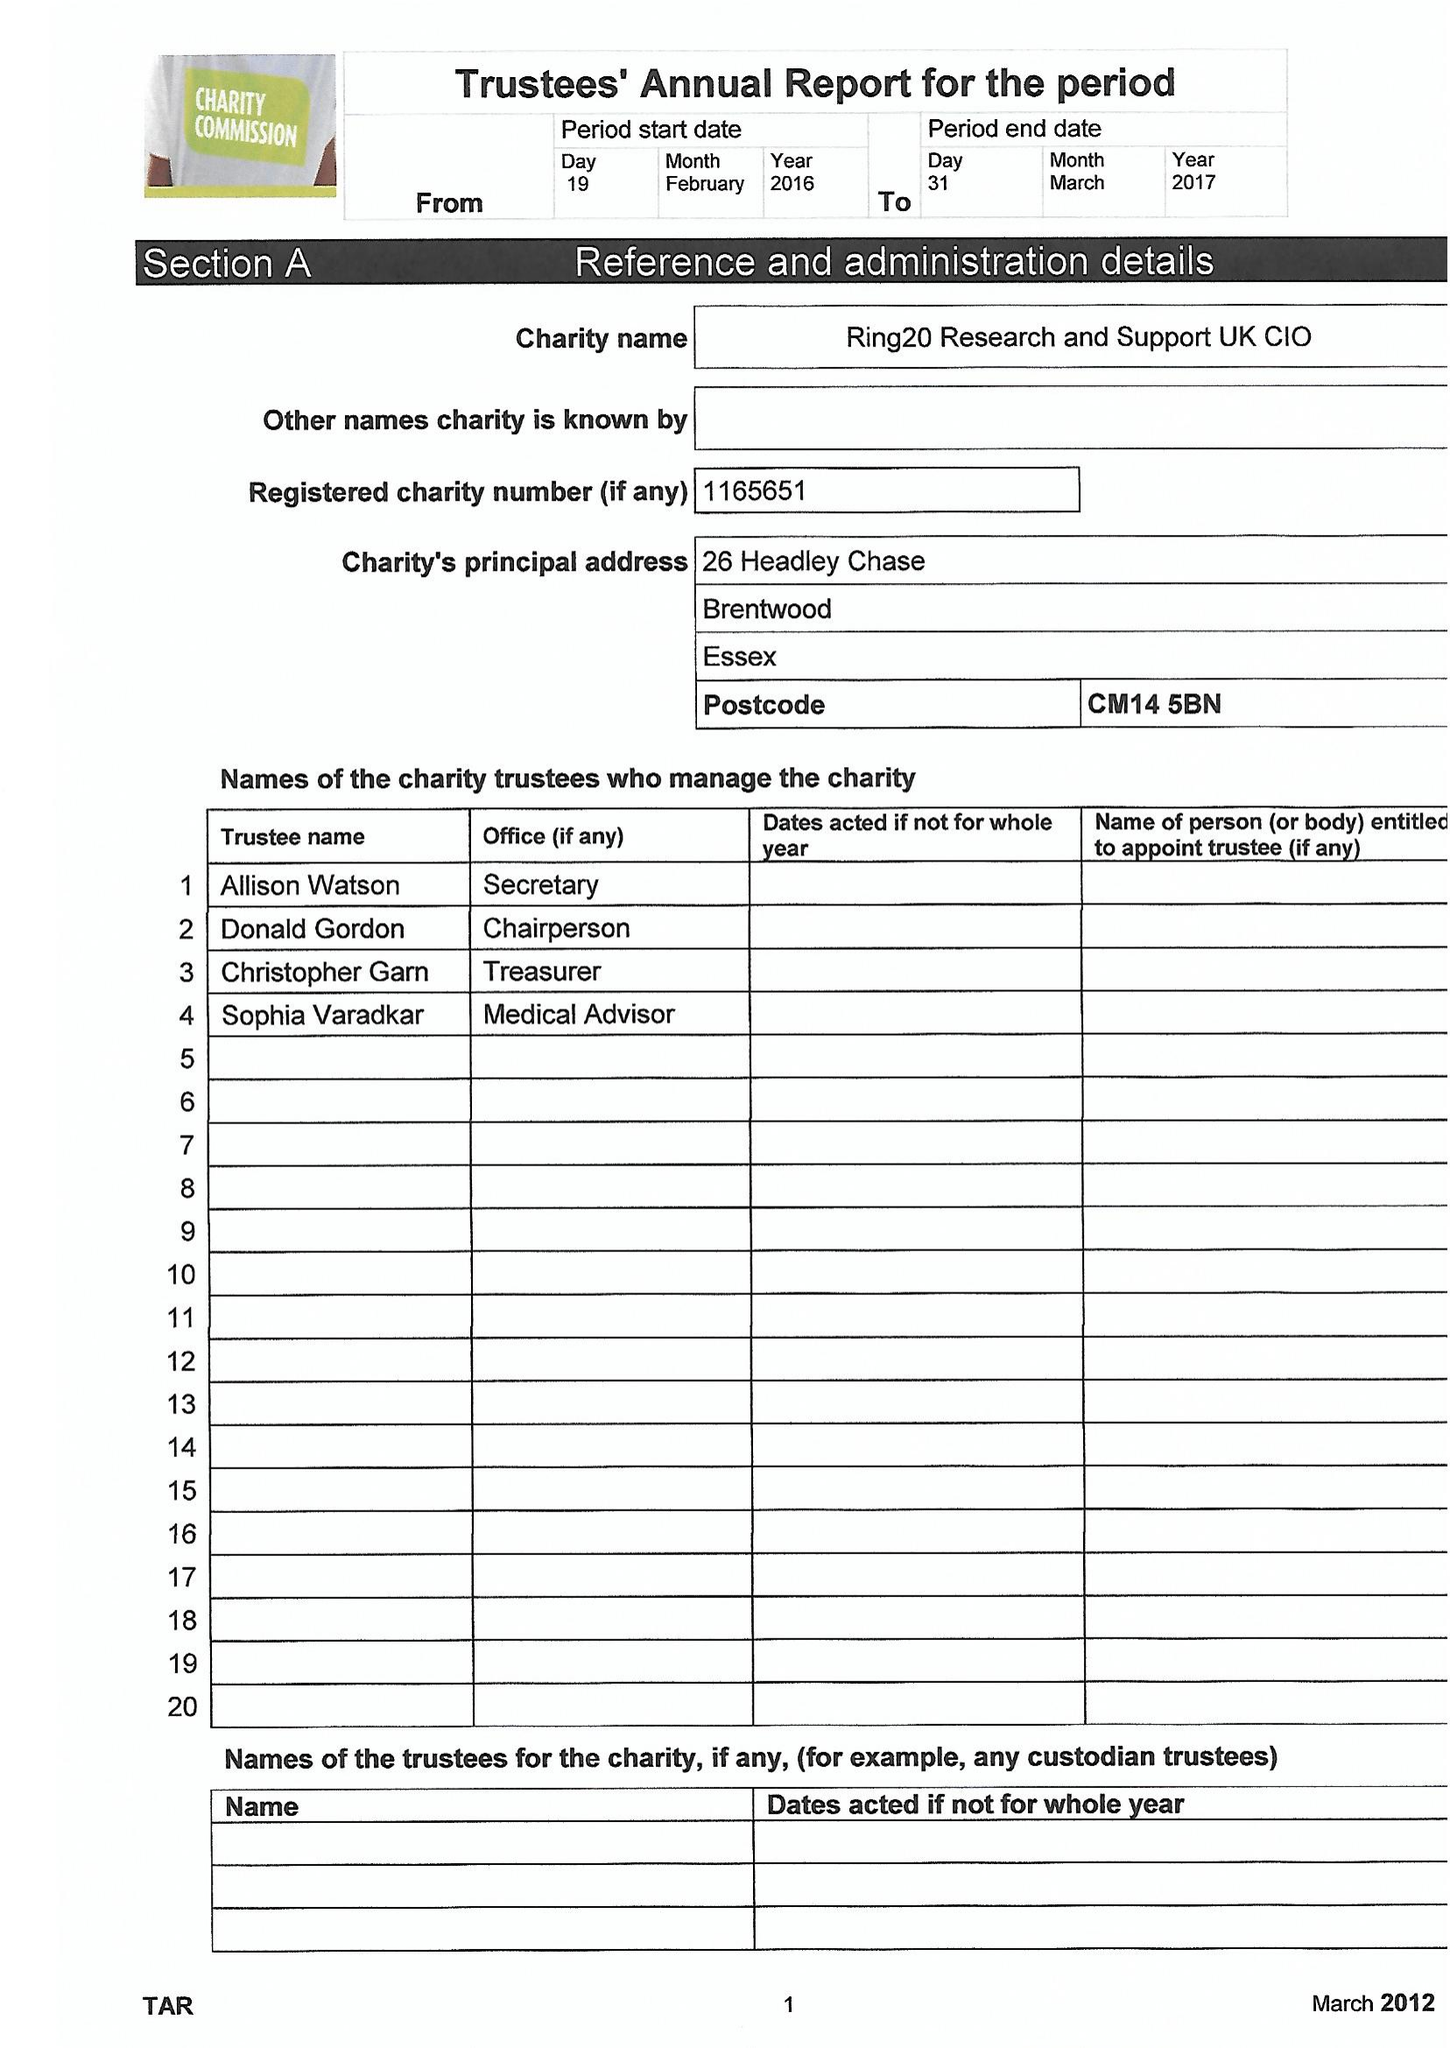What is the value for the address__post_town?
Answer the question using a single word or phrase. BRENTWOOD 